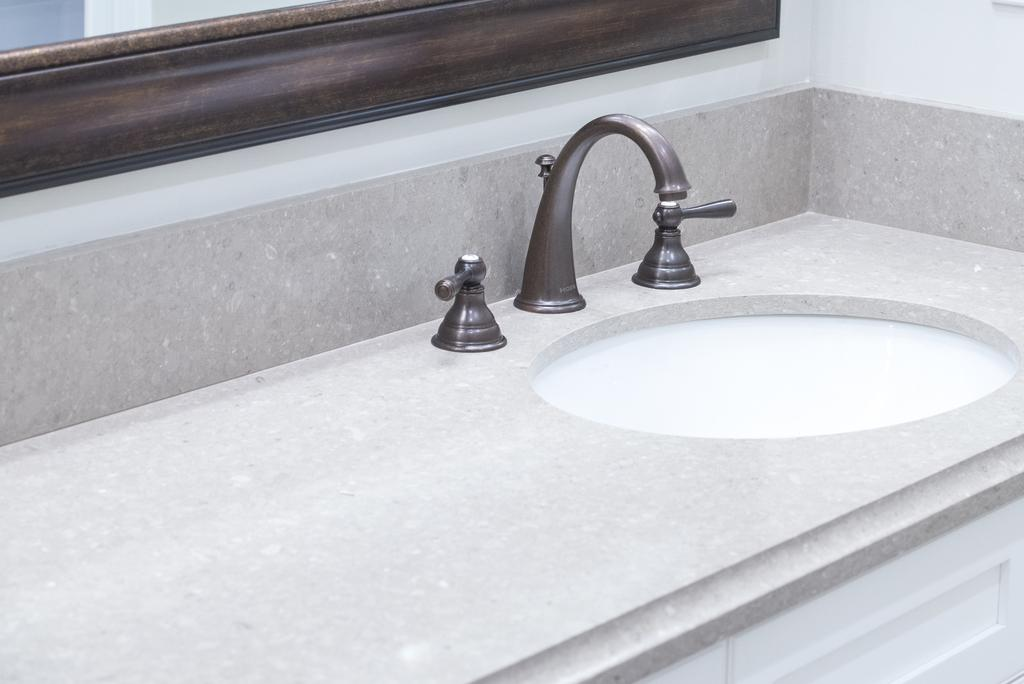What is the main object in the image? There is a tap in the image. What is the tap connected to? The tap is connected to a sink in the image. What can be seen in the background of the image? There is a wooden object in the background of the image. How many spouts does the tap have? The tap has two spouts on both sides. What type of waves can be seen crashing against the shore in the image? There are no waves or shore visible in the image; it features a tap and a sink. What season is depicted in the image, considering the presence of spring flowers? There is no mention of spring flowers or any seasonal elements in the image. 